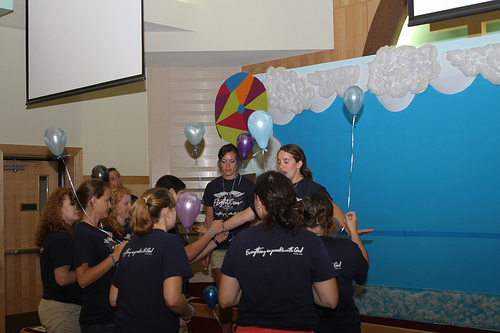<image>
Is there a balloon on the wall? No. The balloon is not positioned on the wall. They may be near each other, but the balloon is not supported by or resting on top of the wall. 